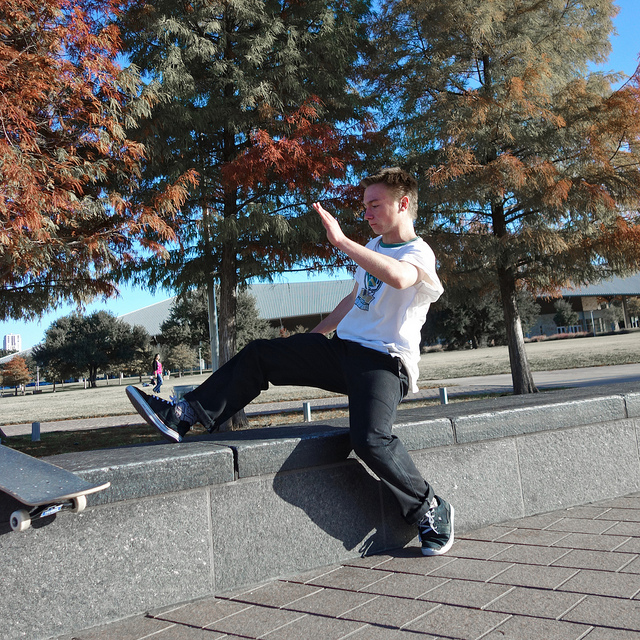<image>What trick is the man performing? I don't know what trick the man is performing. It can be skateboarding, falling or flipping. What trick is the man performing? I am not sure what trick the man is performing. It can be seen as 'skateboard', 'skateboard falling', 'falling', 'none', 'sitting', 'flip', or 'bailing'. 